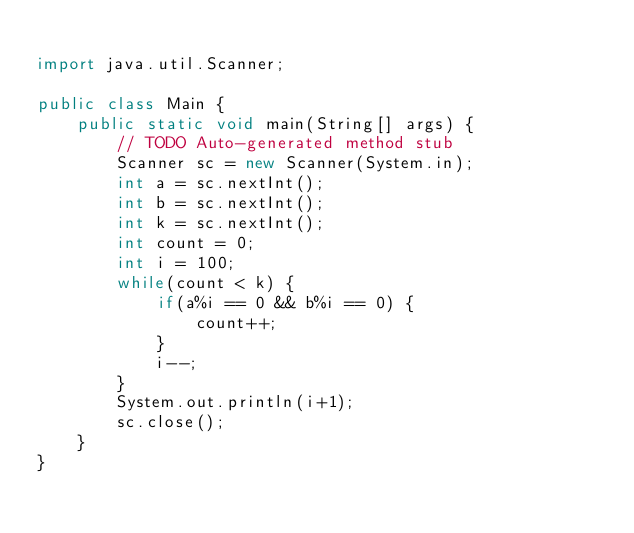<code> <loc_0><loc_0><loc_500><loc_500><_Java_>
import java.util.Scanner;

public class Main {
	public static void main(String[] args) {
		// TODO Auto-generated method stub
		Scanner sc = new Scanner(System.in);
		int a = sc.nextInt();
		int b = sc.nextInt();
		int k = sc.nextInt();
		int count = 0;
		int i = 100;
		while(count < k) {
			if(a%i == 0 && b%i == 0) {
				count++;
			}
			i--;
		}
		System.out.println(i+1);
		sc.close();
	}
}
</code> 